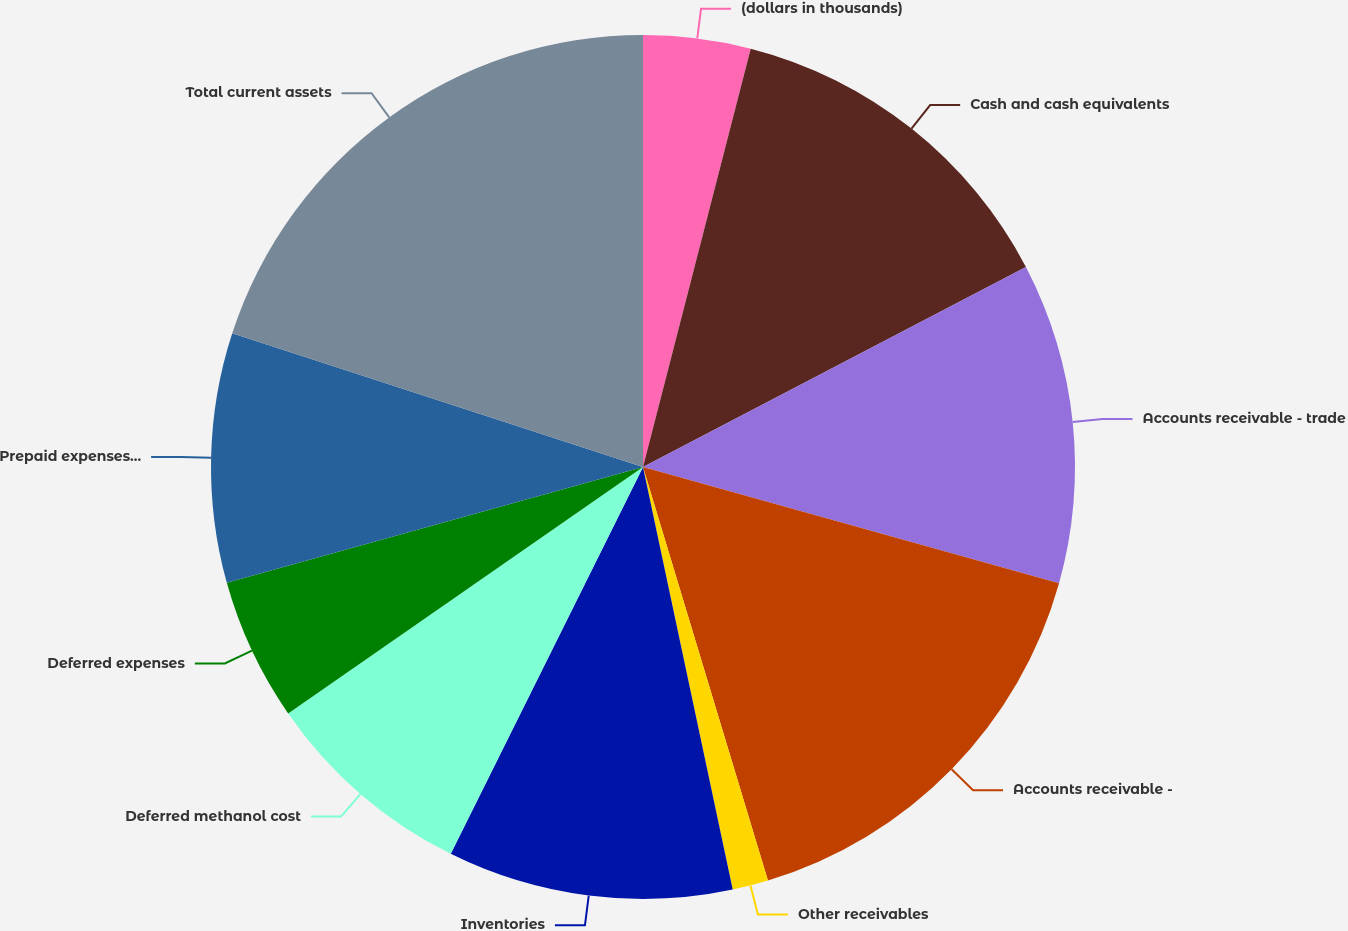Convert chart to OTSL. <chart><loc_0><loc_0><loc_500><loc_500><pie_chart><fcel>(dollars in thousands)<fcel>Cash and cash equivalents<fcel>Accounts receivable - trade<fcel>Accounts receivable -<fcel>Other receivables<fcel>Inventories<fcel>Deferred methanol cost<fcel>Deferred expenses<fcel>Prepaid expenses and deposits<fcel>Total current assets<nl><fcel>4.01%<fcel>13.33%<fcel>12.0%<fcel>15.99%<fcel>1.34%<fcel>10.67%<fcel>8.0%<fcel>5.34%<fcel>9.33%<fcel>19.99%<nl></chart> 